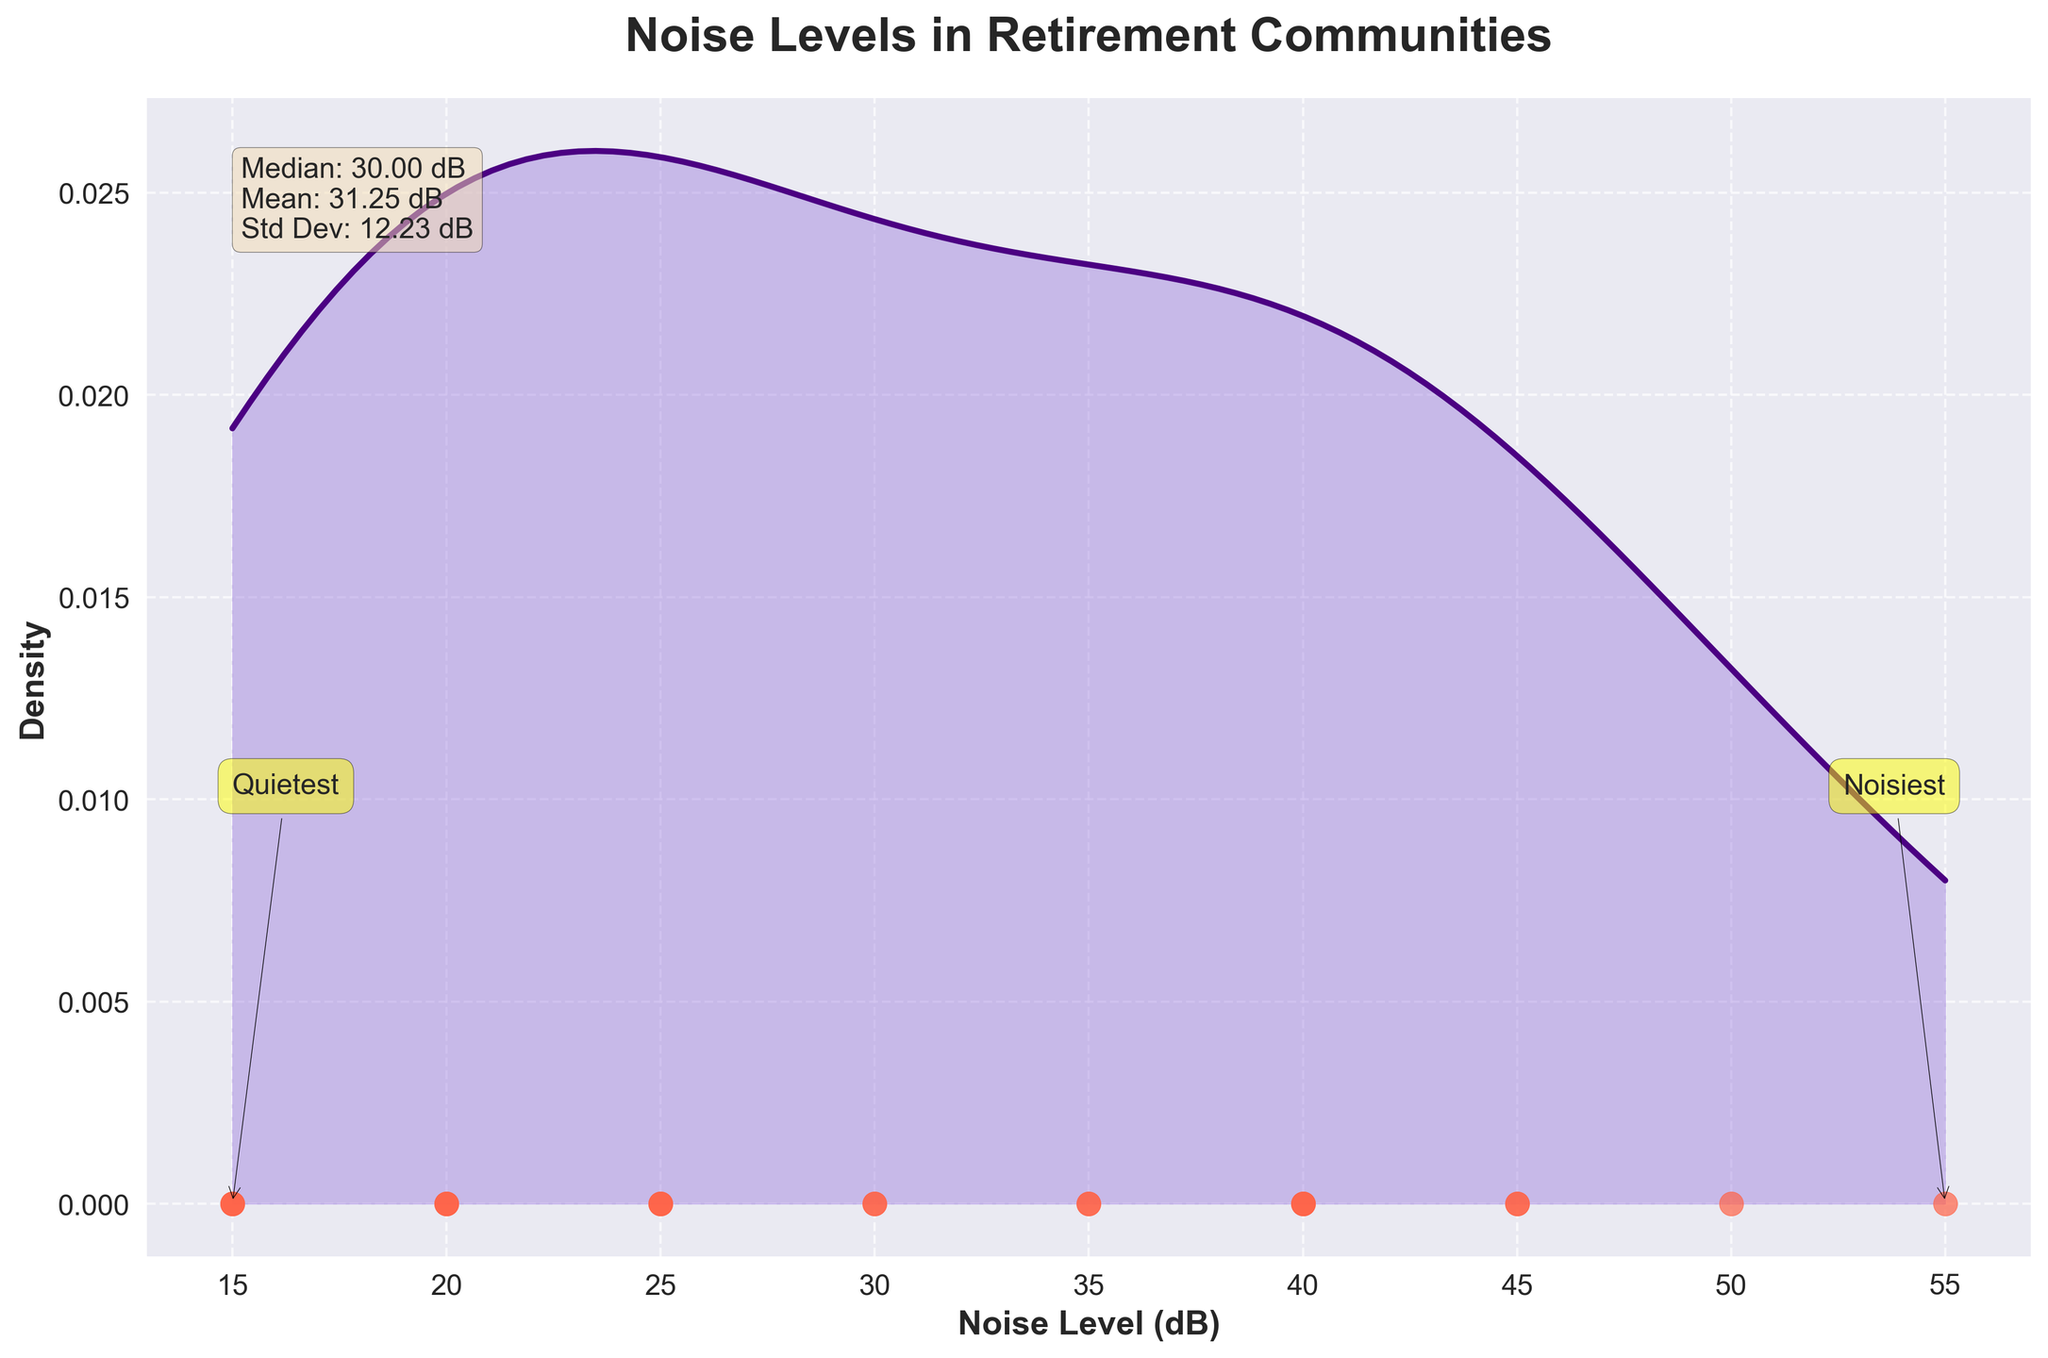What is the title of the figure? The title is displayed at the top center of the figure. It reads: 'Noise Levels in Retirement Communities'.
Answer: 'Noise Levels in Retirement Communities' What does the x-axis represent? The label for the x-axis is 'Noise Level (dB)', indicating it represents noise levels measured in decibels.
Answer: Noise Level (dB) Which location has the lowest noise level? The data points are scattered on the x-axis, indicating their noise levels. The left-most data points have the lowest values. Annotated by the 'Quietest' box, the lowest value is 15 dB, belonging to several communities like Evergreen Countryside Cottages, Silver Birch Country Estates, and Quaint Corners Cottage Community.
Answer: Evergreen Countryside Cottages, Silver Birch Country Estates, Quaint Corners Cottage Community What is the highest noise level recorded in the figure? Observing the scatter points on the x-axis, the right-most point indicates the highest value. Annotated by the 'Noisiest' box, the highest value is 55 dB, corresponding to Golden Years Urban Center.
Answer: 55 dB What is the median noise level? The text box within the plot provides the median value, listed as 'Median: 30.00 dB'.
Answer: 30.00 dB Which retirement community has a noise level of 30 dB? By checking the scatter points, 30 dB corresponds to Serenity Gardens Suburban Homes and Forest Glen Retirement Oasis.
Answer: Serenity Gardens Suburban Homes, Forest Glen Retirement Oasis How many retirement communities have noise levels below 30 dB? From the scatter plot, count the points to the left of 30 dB. There are 10 points corresponding to noise levels below 30 dB.
Answer: 10 What is the range of noise levels in the figure? The range is determined by the minimum and maximum noise levels. The minimum is 15 dB, and the maximum is 55 dB. Therefore, the range is 55 dB - 15 dB = 40 dB.
Answer: 40 dB Compare the noise levels of Sunny Meadows Retirement Village and Lakeview Senior Apartments. Sunny Meadows Retirement Village has a noise level of 45 dB, and Lakeview Senior Apartments also has a noise level of 45 dB. Both have the same noise level.
Answer: Same (45 dB for both) How is the noise data presented besides the scatter plot? The density plot is shown as a smoothed curve, which is shaded underneath to indicate the density of noise levels. Additionally, text annotations highlight the quietest and noisiest extremes.
Answer: As a density curve with shaded areas 